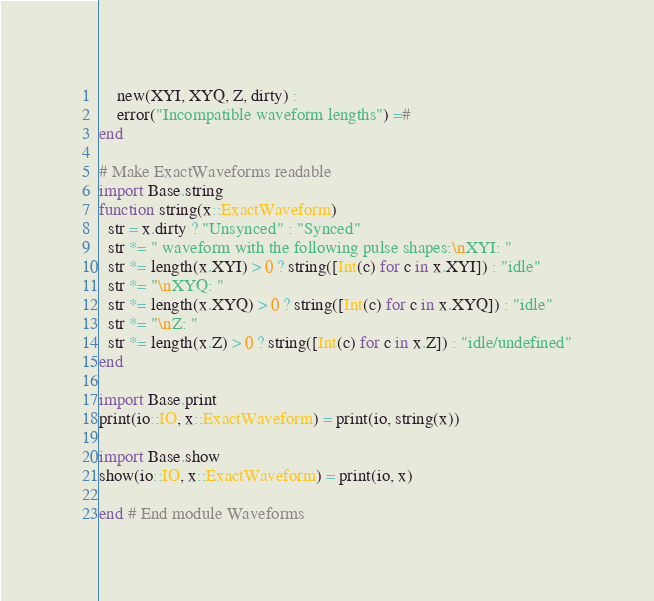<code> <loc_0><loc_0><loc_500><loc_500><_Julia_>    new(XYI, XYQ, Z, dirty) :
    error("Incompatible waveform lengths") =#
end

# Make ExactWaveforms readable
import Base.string
function string(x::ExactWaveform)
  str = x.dirty ? "Unsynced" : "Synced"
  str *= " waveform with the following pulse shapes:\nXYI: "
  str *= length(x.XYI) > 0 ? string([Int(c) for c in x.XYI]) : "idle"
  str *= "\nXYQ: "
  str *= length(x.XYQ) > 0 ? string([Int(c) for c in x.XYQ]) : "idle"
  str *= "\nZ: "
  str *= length(x.Z) > 0 ? string([Int(c) for c in x.Z]) : "idle/undefined"
end

import Base.print
print(io::IO, x::ExactWaveform) = print(io, string(x))

import Base.show
show(io::IO, x::ExactWaveform) = print(io, x)

end # End module Waveforms
</code> 